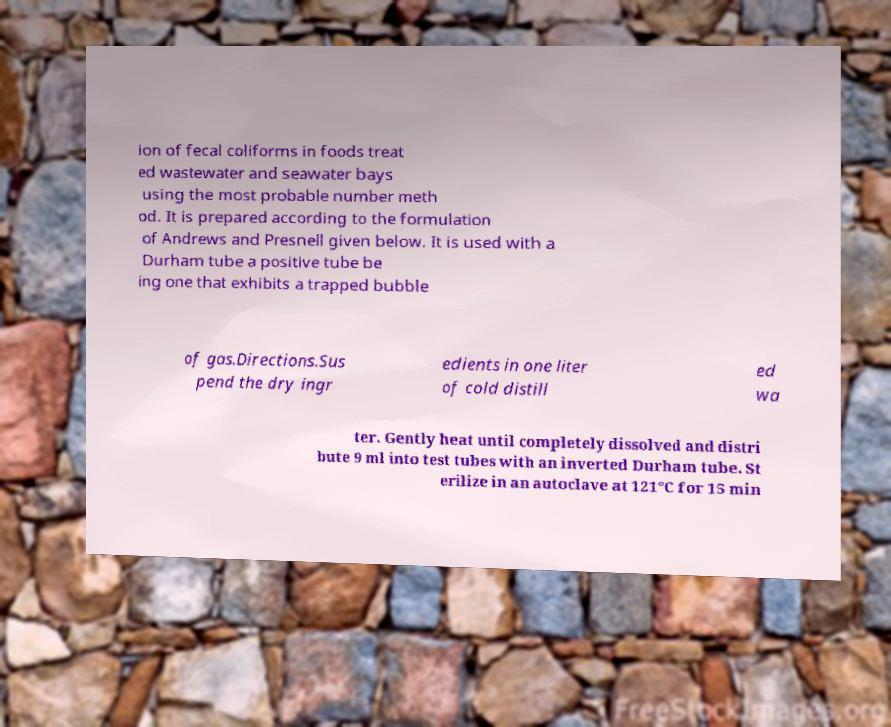Can you read and provide the text displayed in the image?This photo seems to have some interesting text. Can you extract and type it out for me? ion of fecal coliforms in foods treat ed wastewater and seawater bays using the most probable number meth od. It is prepared according to the formulation of Andrews and Presnell given below. It is used with a Durham tube a positive tube be ing one that exhibits a trapped bubble of gas.Directions.Sus pend the dry ingr edients in one liter of cold distill ed wa ter. Gently heat until completely dissolved and distri bute 9 ml into test tubes with an inverted Durham tube. St erilize in an autoclave at 121°C for 15 min 